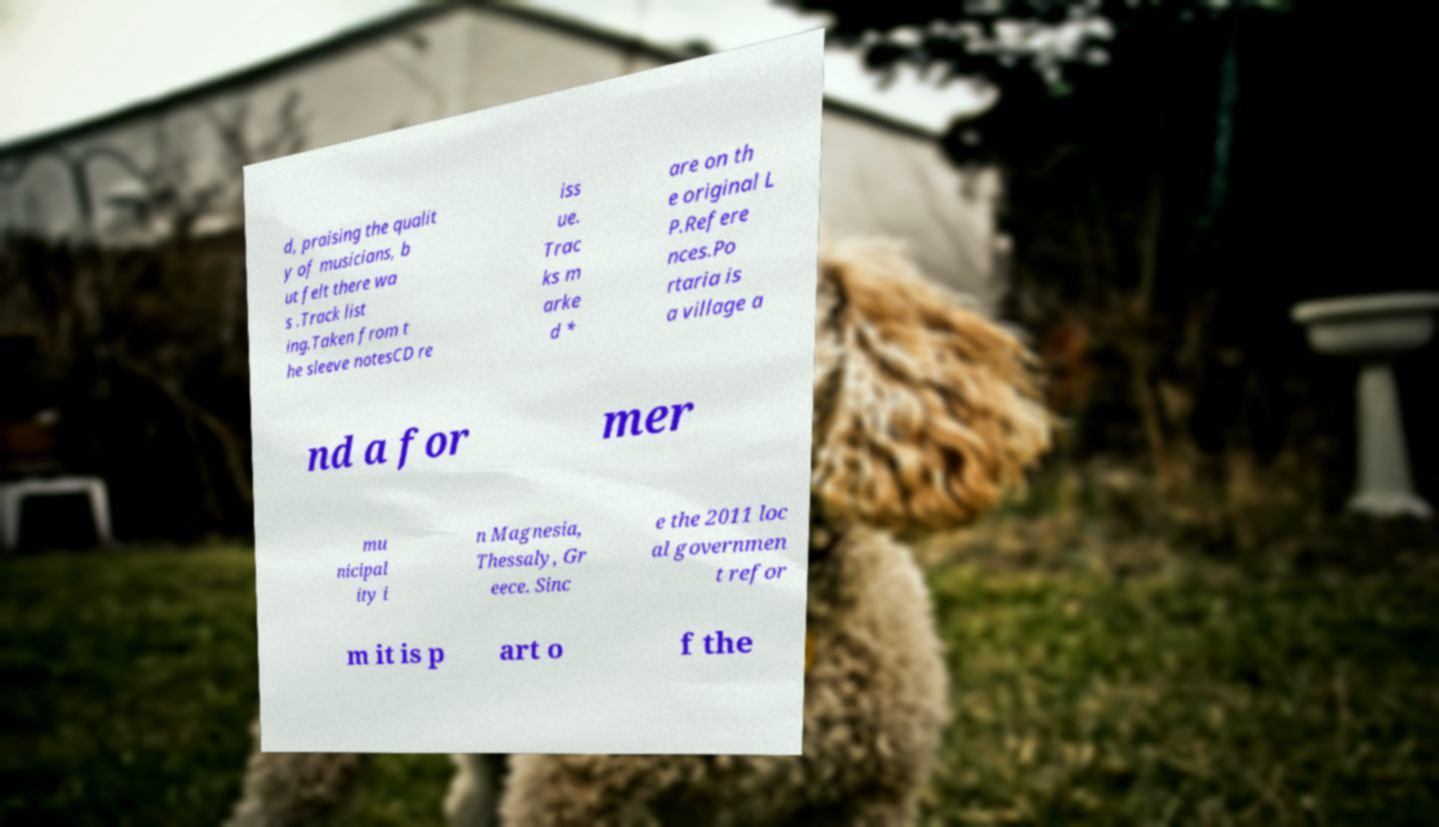I need the written content from this picture converted into text. Can you do that? d, praising the qualit y of musicians, b ut felt there wa s .Track list ing.Taken from t he sleeve notesCD re iss ue. Trac ks m arke d * are on th e original L P.Refere nces.Po rtaria is a village a nd a for mer mu nicipal ity i n Magnesia, Thessaly, Gr eece. Sinc e the 2011 loc al governmen t refor m it is p art o f the 